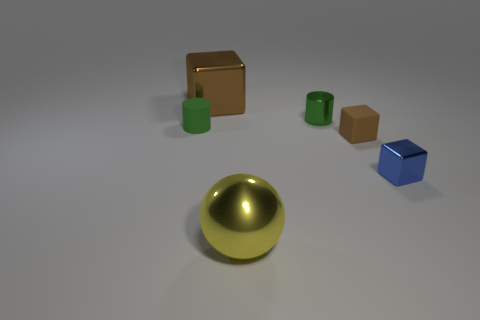Add 2 tiny brown things. How many objects exist? 8 Subtract all big cubes. How many cubes are left? 2 Subtract all brown cubes. How many cubes are left? 1 Add 6 large yellow metallic things. How many large yellow metallic things exist? 7 Subtract 0 red cylinders. How many objects are left? 6 Subtract all cylinders. How many objects are left? 4 Subtract 1 spheres. How many spheres are left? 0 Subtract all yellow blocks. Subtract all gray balls. How many blocks are left? 3 Subtract all brown cylinders. How many blue blocks are left? 1 Subtract all red metal cylinders. Subtract all large metallic blocks. How many objects are left? 5 